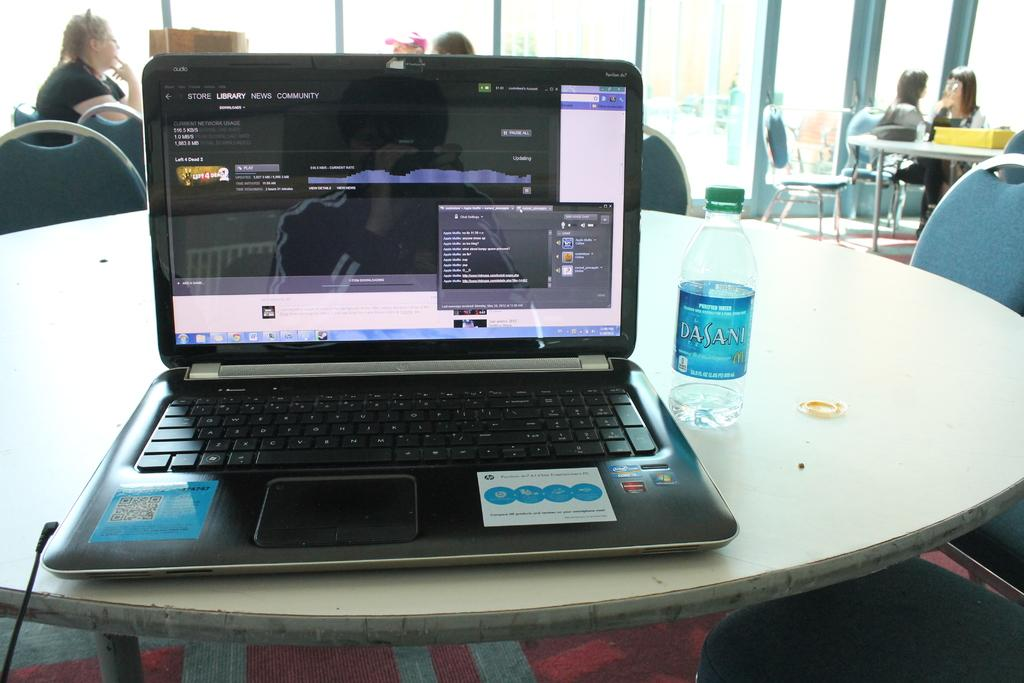<image>
Write a terse but informative summary of the picture. A computer with the "Library" tab open on the screen. 